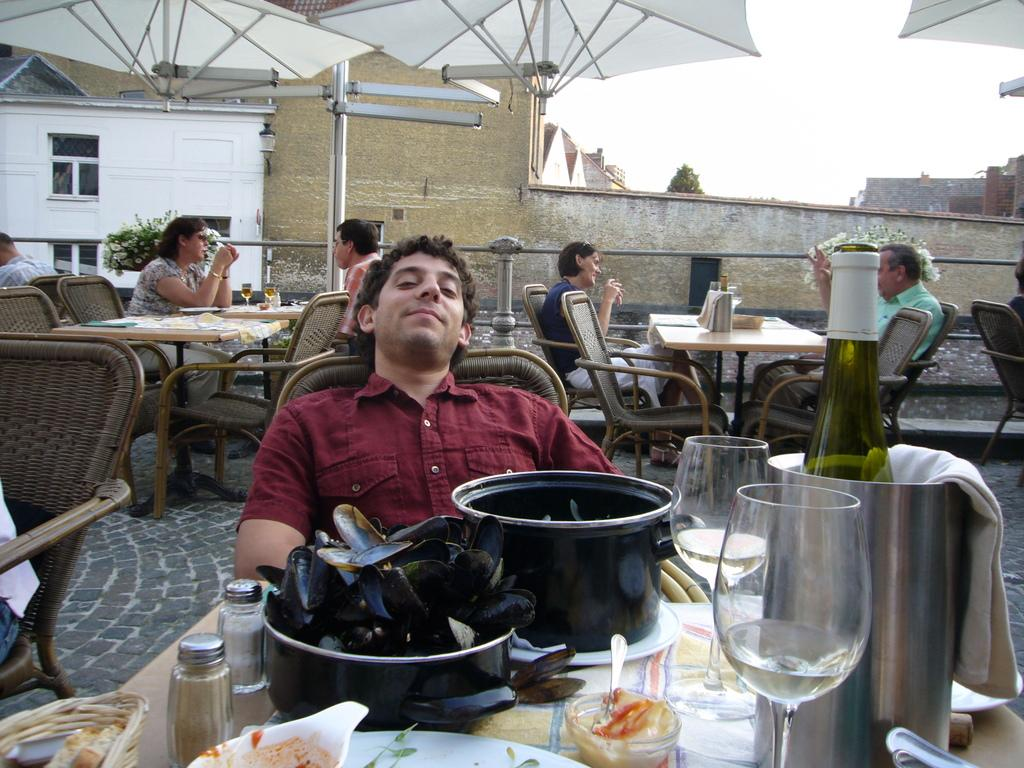What is the person in the image wearing? The person is wearing a red dress in the image. What is the person doing in the image? The person is sitting in a chair in the image. What is in front of the person? There are eatables and drinks in front of the person. What can be seen in the background of the image? There is a group of people and buildings in the background of the image. What type of cap is the person wearing in the image? The person is not wearing a cap in the image; they are wearing a red dress. How much does the ticket cost for the event in the background of the image? There is no event or ticket present in the image; it only shows a person sitting in a chair with eatables and drinks in front of them, along with a background of people and buildings. 